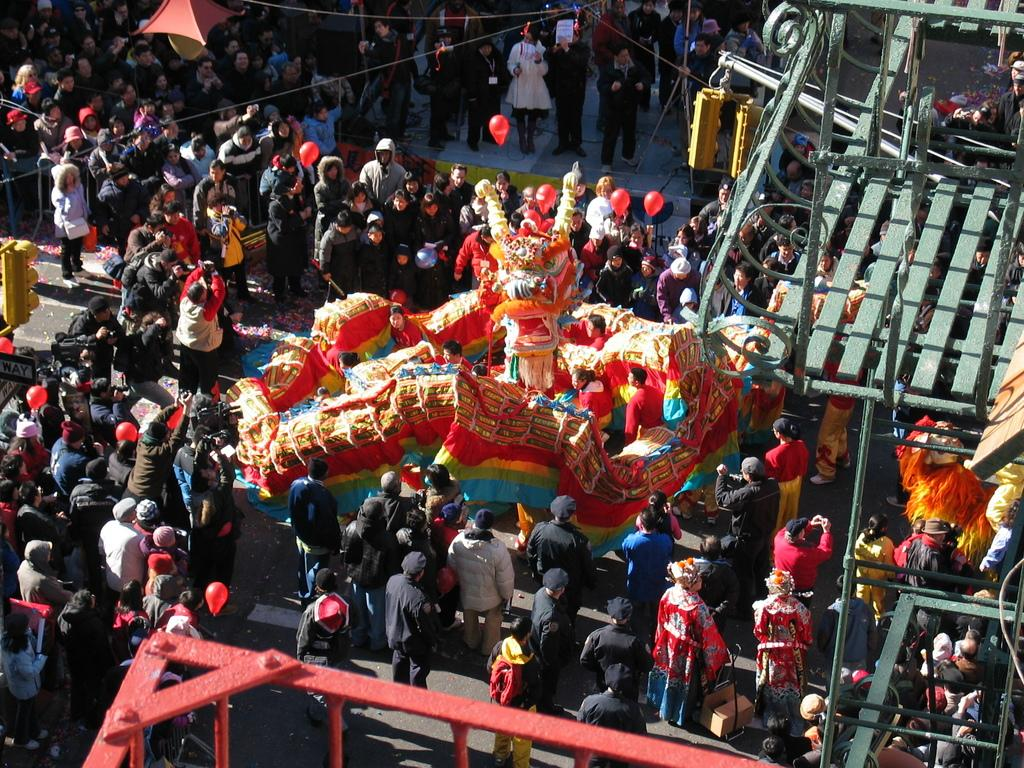What are the people in the image doing? The people in the image are standing on the road. What is the jumping object in the image? There is a jumping balloon in the image. What type of barrier is present in the image? There is a metal fence in the image. What type of balloons can be seen in the image? There are toy balloons in the image. What type of traffic control device is present in the image? Signal lights are present in the image. What type of attack is being carried out by the pigs in the image? There are no pigs present in the image, so no attack can be observed. What type of blade is being used by the person in the image? There is no blade present in the image; the people are simply standing on the road. 